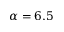<formula> <loc_0><loc_0><loc_500><loc_500>\alpha = 6 . 5</formula> 